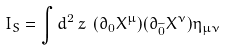Convert formula to latex. <formula><loc_0><loc_0><loc_500><loc_500>I _ { S } = \int d ^ { 2 } \, z \ ( \partial _ { 0 } X ^ { \mu } ) ( \partial _ { \widetilde { 0 } } X ^ { \nu } ) \eta _ { \mu \nu }</formula> 